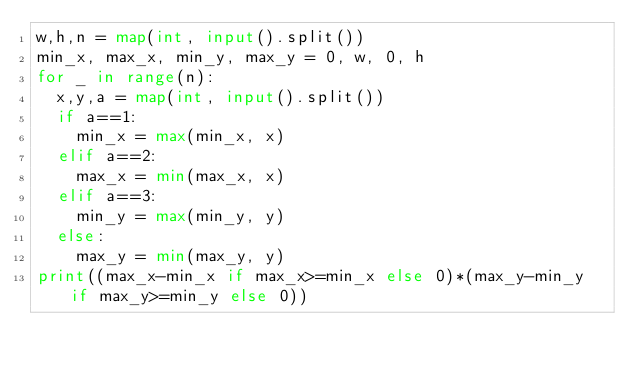<code> <loc_0><loc_0><loc_500><loc_500><_Python_>w,h,n = map(int, input().split())
min_x, max_x, min_y, max_y = 0, w, 0, h
for _ in range(n):
  x,y,a = map(int, input().split())
  if a==1:
    min_x = max(min_x, x)
  elif a==2:
    max_x = min(max_x, x)
  elif a==3:
    min_y = max(min_y, y)
  else:
    max_y = min(max_y, y)
print((max_x-min_x if max_x>=min_x else 0)*(max_y-min_y if max_y>=min_y else 0))
    </code> 